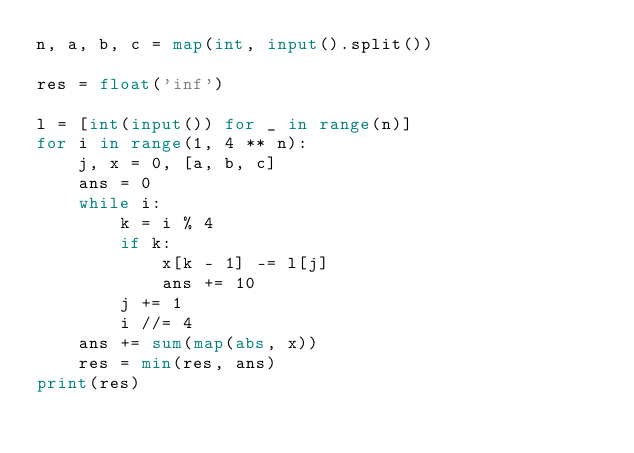<code> <loc_0><loc_0><loc_500><loc_500><_Python_>n, a, b, c = map(int, input().split())

res = float('inf')
    
l = [int(input()) for _ in range(n)]
for i in range(1, 4 ** n):
    j, x = 0, [a, b, c]
    ans = 0
    while i:
        k = i % 4
        if k: 
            x[k - 1] -= l[j]
            ans += 10
        j += 1
        i //= 4
    ans += sum(map(abs, x))
    res = min(res, ans)
print(res)</code> 